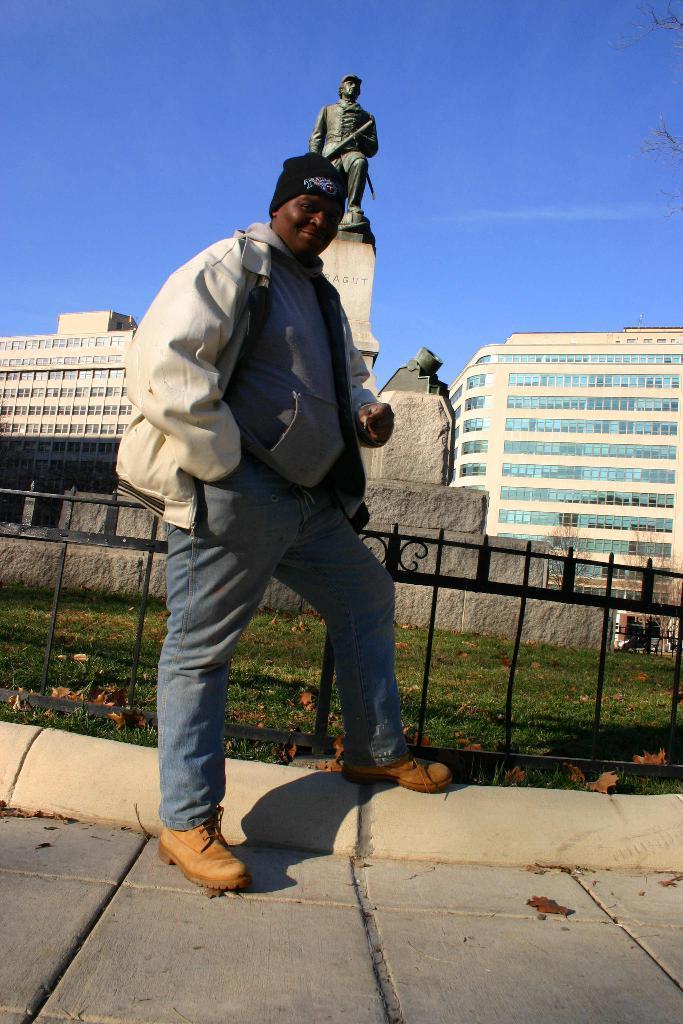Could you give a brief overview of what you see in this image? In the front of the image there is a person, railing, grass, statue and stone. Person wore a jacket and cap. In the background of the image there are buildings and sky. 